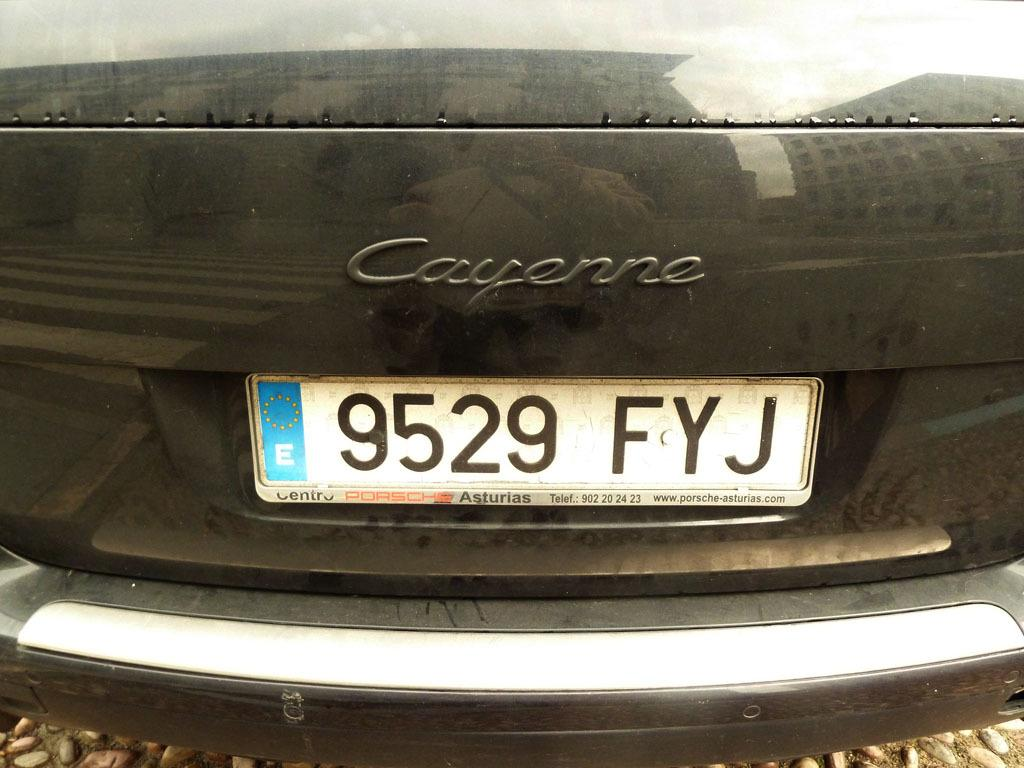Provide a one-sentence caption for the provided image. A close up of a Cayenne car with the licence plate 9529 FYJ. 